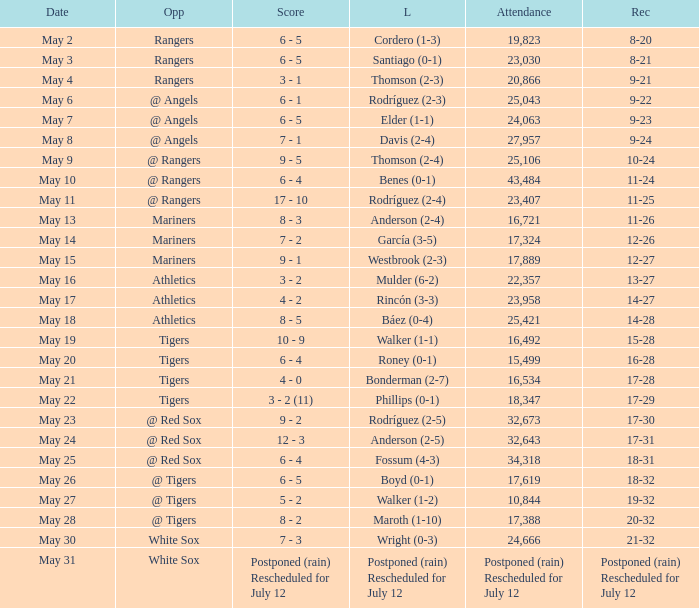What date did the Indians have a record of 14-28? May 18. 